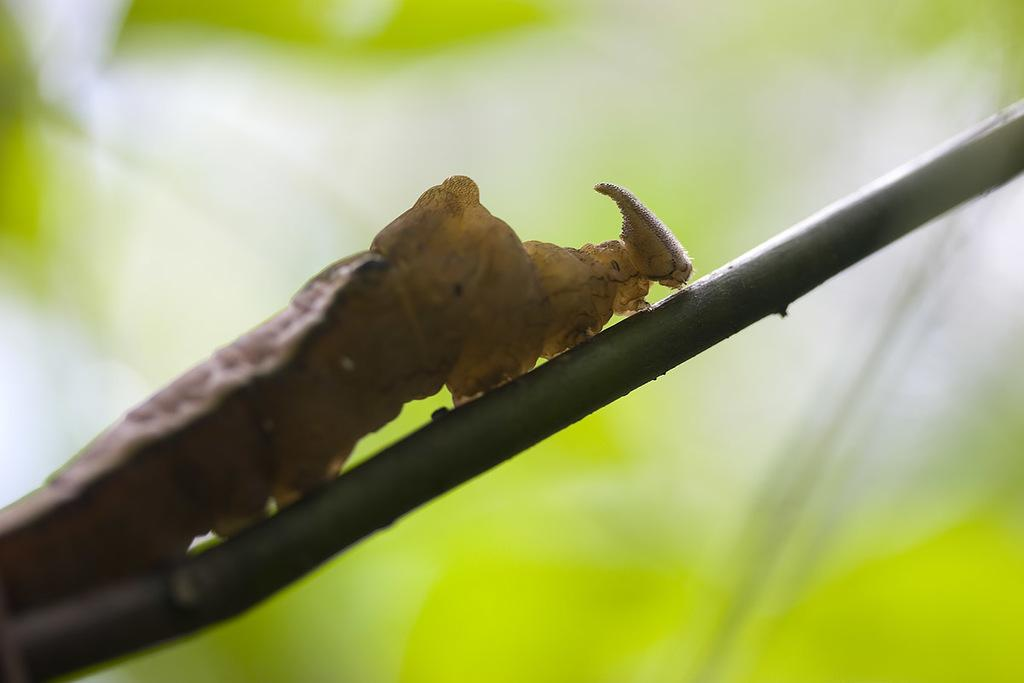What is the main subject of the image? The main subject of the image is a worm. Where is the worm located in the image? The worm is on a stem in the image. What type of rock is the worm using to exercise its brain in the image? There is no rock or exercise for the brain present in the image; it simply features a worm on a stem. 